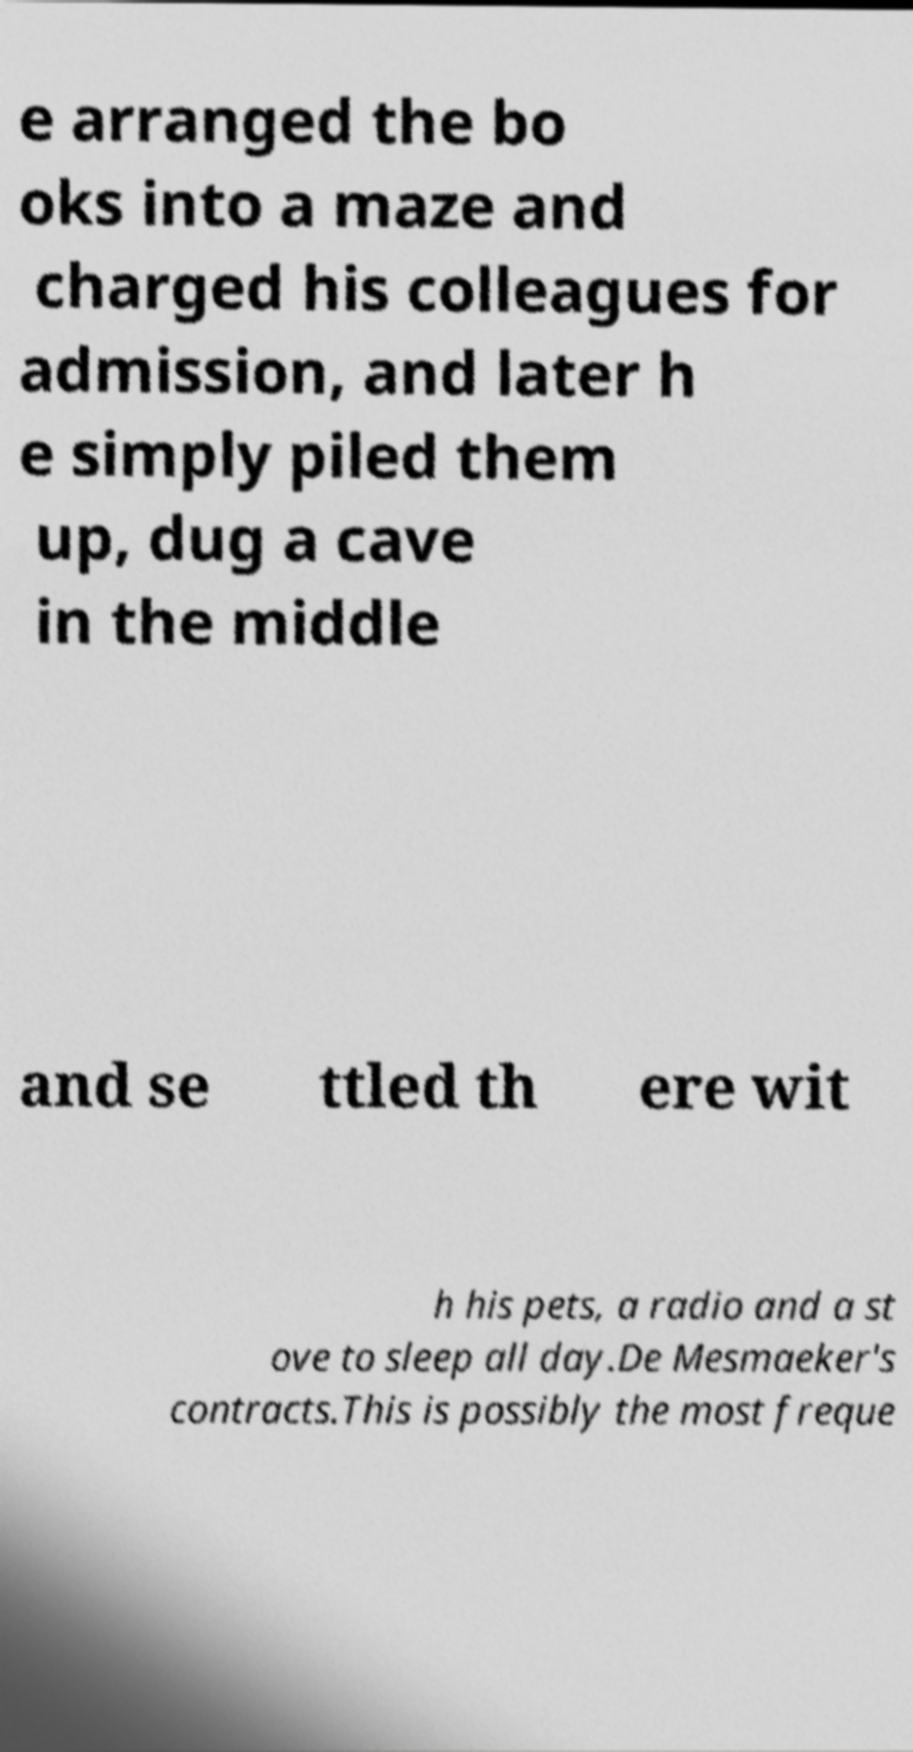Can you read and provide the text displayed in the image?This photo seems to have some interesting text. Can you extract and type it out for me? e arranged the bo oks into a maze and charged his colleagues for admission, and later h e simply piled them up, dug a cave in the middle and se ttled th ere wit h his pets, a radio and a st ove to sleep all day.De Mesmaeker's contracts.This is possibly the most freque 